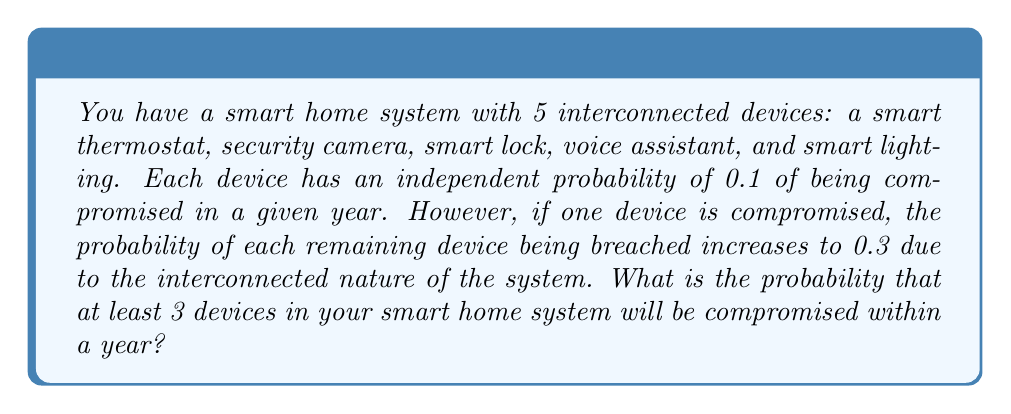Could you help me with this problem? Let's approach this step-by-step:

1) First, we need to calculate the probability of exactly 0, 1, 2, 3, 4, and 5 devices being compromised.

2) For 0 devices compromised:
   $P(0) = (0.9)^5 = 0.59049$

3) For 1 device compromised:
   $P(1) = \binom{5}{1} \cdot 0.1 \cdot (0.9)^4 = 5 \cdot 0.1 \cdot 0.6561 = 0.32805$

4) For 2 or more devices, we need to consider the increased probability for remaining devices:

   For 2 devices:
   $P(2) = \binom{5}{1} \cdot 0.1 \cdot \binom{4}{1} \cdot 0.3 \cdot (0.7)^3 = 5 \cdot 0.1 \cdot 4 \cdot 0.3 \cdot 0.343 = 0.2058$

   For 3 devices:
   $P(3) = \binom{5}{1} \cdot 0.1 \cdot \binom{4}{1} \cdot 0.3 \cdot \binom{3}{1} \cdot 0.3 \cdot (0.7)^2 = 5 \cdot 0.1 \cdot 4 \cdot 0.3 \cdot 3 \cdot 0.3 \cdot 0.49 = 0.08820$

   For 4 devices:
   $P(4) = \binom{5}{1} \cdot 0.1 \cdot \binom{4}{1} \cdot 0.3 \cdot \binom{3}{1} \cdot 0.3 \cdot \binom{2}{1} \cdot 0.3 \cdot 0.7 = 5 \cdot 0.1 \cdot 4 \cdot 0.3 \cdot 3 \cdot 0.3 \cdot 2 \cdot 0.3 \cdot 0.7 = 0.01890$

   For 5 devices:
   $P(5) = \binom{5}{1} \cdot 0.1 \cdot \binom{4}{1} \cdot 0.3 \cdot \binom{3}{1} \cdot 0.3 \cdot \binom{2}{1} \cdot 0.3 \cdot 0.3 = 5 \cdot 0.1 \cdot 4 \cdot 0.3 \cdot 3 \cdot 0.3 \cdot 2 \cdot 0.3 \cdot 0.3 = 0.00486$

5) The probability of at least 3 devices being compromised is the sum of P(3), P(4), and P(5):

   $P(\text{at least 3}) = 0.08820 + 0.01890 + 0.00486 = 0.11196$

Therefore, the probability that at least 3 devices in your smart home system will be compromised within a year is approximately 0.11196 or 11.196%.
Answer: 0.11196 